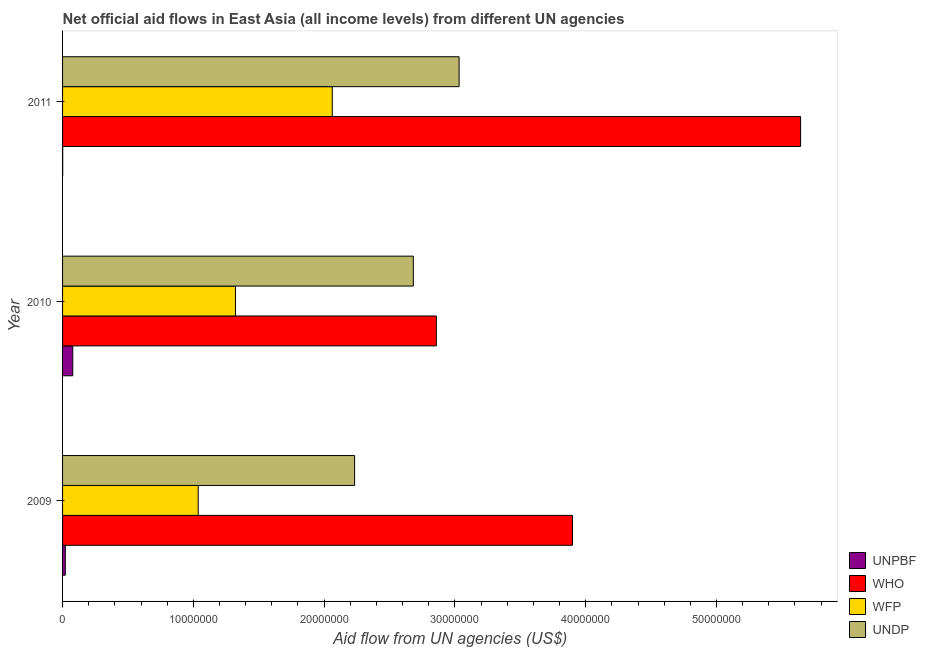How many different coloured bars are there?
Provide a short and direct response. 4. Are the number of bars on each tick of the Y-axis equal?
Make the answer very short. Yes. How many bars are there on the 2nd tick from the top?
Provide a succinct answer. 4. How many bars are there on the 1st tick from the bottom?
Offer a very short reply. 4. What is the amount of aid given by wfp in 2011?
Ensure brevity in your answer.  2.06e+07. Across all years, what is the maximum amount of aid given by undp?
Offer a very short reply. 3.03e+07. Across all years, what is the minimum amount of aid given by undp?
Provide a short and direct response. 2.23e+07. In which year was the amount of aid given by wfp maximum?
Your answer should be very brief. 2011. In which year was the amount of aid given by unpbf minimum?
Provide a short and direct response. 2011. What is the total amount of aid given by undp in the graph?
Offer a very short reply. 7.95e+07. What is the difference between the amount of aid given by unpbf in 2010 and that in 2011?
Provide a succinct answer. 7.70e+05. What is the difference between the amount of aid given by wfp in 2009 and the amount of aid given by who in 2011?
Offer a terse response. -4.61e+07. What is the average amount of aid given by undp per year?
Offer a very short reply. 2.65e+07. In the year 2011, what is the difference between the amount of aid given by undp and amount of aid given by unpbf?
Ensure brevity in your answer.  3.03e+07. In how many years, is the amount of aid given by who greater than 52000000 US$?
Provide a short and direct response. 1. What is the ratio of the amount of aid given by wfp in 2009 to that in 2011?
Provide a succinct answer. 0.5. Is the difference between the amount of aid given by wfp in 2010 and 2011 greater than the difference between the amount of aid given by unpbf in 2010 and 2011?
Keep it short and to the point. No. What is the difference between the highest and the second highest amount of aid given by undp?
Provide a succinct answer. 3.50e+06. What is the difference between the highest and the lowest amount of aid given by unpbf?
Your answer should be compact. 7.70e+05. In how many years, is the amount of aid given by undp greater than the average amount of aid given by undp taken over all years?
Give a very brief answer. 2. Is it the case that in every year, the sum of the amount of aid given by who and amount of aid given by wfp is greater than the sum of amount of aid given by undp and amount of aid given by unpbf?
Your answer should be very brief. Yes. What does the 3rd bar from the top in 2011 represents?
Provide a succinct answer. WHO. What does the 4th bar from the bottom in 2009 represents?
Offer a terse response. UNDP. Is it the case that in every year, the sum of the amount of aid given by unpbf and amount of aid given by who is greater than the amount of aid given by wfp?
Give a very brief answer. Yes. Are all the bars in the graph horizontal?
Make the answer very short. Yes. How many years are there in the graph?
Give a very brief answer. 3. Are the values on the major ticks of X-axis written in scientific E-notation?
Ensure brevity in your answer.  No. Does the graph contain any zero values?
Provide a succinct answer. No. How are the legend labels stacked?
Provide a succinct answer. Vertical. What is the title of the graph?
Give a very brief answer. Net official aid flows in East Asia (all income levels) from different UN agencies. Does "Australia" appear as one of the legend labels in the graph?
Your answer should be compact. No. What is the label or title of the X-axis?
Offer a terse response. Aid flow from UN agencies (US$). What is the Aid flow from UN agencies (US$) of WHO in 2009?
Make the answer very short. 3.90e+07. What is the Aid flow from UN agencies (US$) in WFP in 2009?
Offer a terse response. 1.04e+07. What is the Aid flow from UN agencies (US$) in UNDP in 2009?
Offer a terse response. 2.23e+07. What is the Aid flow from UN agencies (US$) of UNPBF in 2010?
Your response must be concise. 7.80e+05. What is the Aid flow from UN agencies (US$) of WHO in 2010?
Provide a succinct answer. 2.86e+07. What is the Aid flow from UN agencies (US$) of WFP in 2010?
Keep it short and to the point. 1.32e+07. What is the Aid flow from UN agencies (US$) of UNDP in 2010?
Offer a very short reply. 2.68e+07. What is the Aid flow from UN agencies (US$) in WHO in 2011?
Provide a succinct answer. 5.64e+07. What is the Aid flow from UN agencies (US$) in WFP in 2011?
Ensure brevity in your answer.  2.06e+07. What is the Aid flow from UN agencies (US$) in UNDP in 2011?
Your answer should be very brief. 3.03e+07. Across all years, what is the maximum Aid flow from UN agencies (US$) of UNPBF?
Your answer should be compact. 7.80e+05. Across all years, what is the maximum Aid flow from UN agencies (US$) in WHO?
Give a very brief answer. 5.64e+07. Across all years, what is the maximum Aid flow from UN agencies (US$) of WFP?
Your answer should be compact. 2.06e+07. Across all years, what is the maximum Aid flow from UN agencies (US$) of UNDP?
Your response must be concise. 3.03e+07. Across all years, what is the minimum Aid flow from UN agencies (US$) in WHO?
Ensure brevity in your answer.  2.86e+07. Across all years, what is the minimum Aid flow from UN agencies (US$) of WFP?
Keep it short and to the point. 1.04e+07. Across all years, what is the minimum Aid flow from UN agencies (US$) in UNDP?
Give a very brief answer. 2.23e+07. What is the total Aid flow from UN agencies (US$) of UNPBF in the graph?
Offer a very short reply. 1.00e+06. What is the total Aid flow from UN agencies (US$) in WHO in the graph?
Your answer should be very brief. 1.24e+08. What is the total Aid flow from UN agencies (US$) of WFP in the graph?
Your answer should be compact. 4.42e+07. What is the total Aid flow from UN agencies (US$) in UNDP in the graph?
Offer a very short reply. 7.95e+07. What is the difference between the Aid flow from UN agencies (US$) in UNPBF in 2009 and that in 2010?
Your answer should be compact. -5.70e+05. What is the difference between the Aid flow from UN agencies (US$) in WHO in 2009 and that in 2010?
Your answer should be compact. 1.04e+07. What is the difference between the Aid flow from UN agencies (US$) in WFP in 2009 and that in 2010?
Provide a succinct answer. -2.85e+06. What is the difference between the Aid flow from UN agencies (US$) of UNDP in 2009 and that in 2010?
Your answer should be very brief. -4.49e+06. What is the difference between the Aid flow from UN agencies (US$) in UNPBF in 2009 and that in 2011?
Offer a very short reply. 2.00e+05. What is the difference between the Aid flow from UN agencies (US$) of WHO in 2009 and that in 2011?
Your answer should be compact. -1.74e+07. What is the difference between the Aid flow from UN agencies (US$) in WFP in 2009 and that in 2011?
Give a very brief answer. -1.02e+07. What is the difference between the Aid flow from UN agencies (US$) of UNDP in 2009 and that in 2011?
Provide a succinct answer. -7.99e+06. What is the difference between the Aid flow from UN agencies (US$) of UNPBF in 2010 and that in 2011?
Your answer should be compact. 7.70e+05. What is the difference between the Aid flow from UN agencies (US$) of WHO in 2010 and that in 2011?
Ensure brevity in your answer.  -2.78e+07. What is the difference between the Aid flow from UN agencies (US$) in WFP in 2010 and that in 2011?
Ensure brevity in your answer.  -7.40e+06. What is the difference between the Aid flow from UN agencies (US$) in UNDP in 2010 and that in 2011?
Provide a succinct answer. -3.50e+06. What is the difference between the Aid flow from UN agencies (US$) of UNPBF in 2009 and the Aid flow from UN agencies (US$) of WHO in 2010?
Your answer should be compact. -2.84e+07. What is the difference between the Aid flow from UN agencies (US$) of UNPBF in 2009 and the Aid flow from UN agencies (US$) of WFP in 2010?
Make the answer very short. -1.30e+07. What is the difference between the Aid flow from UN agencies (US$) of UNPBF in 2009 and the Aid flow from UN agencies (US$) of UNDP in 2010?
Provide a succinct answer. -2.66e+07. What is the difference between the Aid flow from UN agencies (US$) in WHO in 2009 and the Aid flow from UN agencies (US$) in WFP in 2010?
Offer a terse response. 2.58e+07. What is the difference between the Aid flow from UN agencies (US$) of WHO in 2009 and the Aid flow from UN agencies (US$) of UNDP in 2010?
Provide a short and direct response. 1.22e+07. What is the difference between the Aid flow from UN agencies (US$) of WFP in 2009 and the Aid flow from UN agencies (US$) of UNDP in 2010?
Your answer should be compact. -1.64e+07. What is the difference between the Aid flow from UN agencies (US$) of UNPBF in 2009 and the Aid flow from UN agencies (US$) of WHO in 2011?
Ensure brevity in your answer.  -5.62e+07. What is the difference between the Aid flow from UN agencies (US$) in UNPBF in 2009 and the Aid flow from UN agencies (US$) in WFP in 2011?
Offer a terse response. -2.04e+07. What is the difference between the Aid flow from UN agencies (US$) in UNPBF in 2009 and the Aid flow from UN agencies (US$) in UNDP in 2011?
Your response must be concise. -3.01e+07. What is the difference between the Aid flow from UN agencies (US$) of WHO in 2009 and the Aid flow from UN agencies (US$) of WFP in 2011?
Offer a terse response. 1.84e+07. What is the difference between the Aid flow from UN agencies (US$) in WHO in 2009 and the Aid flow from UN agencies (US$) in UNDP in 2011?
Offer a terse response. 8.67e+06. What is the difference between the Aid flow from UN agencies (US$) of WFP in 2009 and the Aid flow from UN agencies (US$) of UNDP in 2011?
Your response must be concise. -2.00e+07. What is the difference between the Aid flow from UN agencies (US$) of UNPBF in 2010 and the Aid flow from UN agencies (US$) of WHO in 2011?
Your response must be concise. -5.56e+07. What is the difference between the Aid flow from UN agencies (US$) in UNPBF in 2010 and the Aid flow from UN agencies (US$) in WFP in 2011?
Ensure brevity in your answer.  -1.98e+07. What is the difference between the Aid flow from UN agencies (US$) in UNPBF in 2010 and the Aid flow from UN agencies (US$) in UNDP in 2011?
Offer a very short reply. -2.95e+07. What is the difference between the Aid flow from UN agencies (US$) of WHO in 2010 and the Aid flow from UN agencies (US$) of WFP in 2011?
Give a very brief answer. 7.96e+06. What is the difference between the Aid flow from UN agencies (US$) in WHO in 2010 and the Aid flow from UN agencies (US$) in UNDP in 2011?
Give a very brief answer. -1.74e+06. What is the difference between the Aid flow from UN agencies (US$) of WFP in 2010 and the Aid flow from UN agencies (US$) of UNDP in 2011?
Give a very brief answer. -1.71e+07. What is the average Aid flow from UN agencies (US$) in UNPBF per year?
Your answer should be very brief. 3.33e+05. What is the average Aid flow from UN agencies (US$) in WHO per year?
Provide a succinct answer. 4.13e+07. What is the average Aid flow from UN agencies (US$) in WFP per year?
Your answer should be very brief. 1.47e+07. What is the average Aid flow from UN agencies (US$) of UNDP per year?
Provide a short and direct response. 2.65e+07. In the year 2009, what is the difference between the Aid flow from UN agencies (US$) of UNPBF and Aid flow from UN agencies (US$) of WHO?
Provide a succinct answer. -3.88e+07. In the year 2009, what is the difference between the Aid flow from UN agencies (US$) of UNPBF and Aid flow from UN agencies (US$) of WFP?
Your response must be concise. -1.02e+07. In the year 2009, what is the difference between the Aid flow from UN agencies (US$) in UNPBF and Aid flow from UN agencies (US$) in UNDP?
Keep it short and to the point. -2.21e+07. In the year 2009, what is the difference between the Aid flow from UN agencies (US$) of WHO and Aid flow from UN agencies (US$) of WFP?
Offer a terse response. 2.86e+07. In the year 2009, what is the difference between the Aid flow from UN agencies (US$) in WHO and Aid flow from UN agencies (US$) in UNDP?
Offer a terse response. 1.67e+07. In the year 2009, what is the difference between the Aid flow from UN agencies (US$) in WFP and Aid flow from UN agencies (US$) in UNDP?
Offer a terse response. -1.20e+07. In the year 2010, what is the difference between the Aid flow from UN agencies (US$) in UNPBF and Aid flow from UN agencies (US$) in WHO?
Your answer should be compact. -2.78e+07. In the year 2010, what is the difference between the Aid flow from UN agencies (US$) in UNPBF and Aid flow from UN agencies (US$) in WFP?
Offer a very short reply. -1.24e+07. In the year 2010, what is the difference between the Aid flow from UN agencies (US$) of UNPBF and Aid flow from UN agencies (US$) of UNDP?
Your answer should be compact. -2.60e+07. In the year 2010, what is the difference between the Aid flow from UN agencies (US$) in WHO and Aid flow from UN agencies (US$) in WFP?
Your answer should be very brief. 1.54e+07. In the year 2010, what is the difference between the Aid flow from UN agencies (US$) of WHO and Aid flow from UN agencies (US$) of UNDP?
Keep it short and to the point. 1.76e+06. In the year 2010, what is the difference between the Aid flow from UN agencies (US$) of WFP and Aid flow from UN agencies (US$) of UNDP?
Give a very brief answer. -1.36e+07. In the year 2011, what is the difference between the Aid flow from UN agencies (US$) of UNPBF and Aid flow from UN agencies (US$) of WHO?
Offer a terse response. -5.64e+07. In the year 2011, what is the difference between the Aid flow from UN agencies (US$) of UNPBF and Aid flow from UN agencies (US$) of WFP?
Keep it short and to the point. -2.06e+07. In the year 2011, what is the difference between the Aid flow from UN agencies (US$) in UNPBF and Aid flow from UN agencies (US$) in UNDP?
Your answer should be very brief. -3.03e+07. In the year 2011, what is the difference between the Aid flow from UN agencies (US$) of WHO and Aid flow from UN agencies (US$) of WFP?
Ensure brevity in your answer.  3.58e+07. In the year 2011, what is the difference between the Aid flow from UN agencies (US$) in WHO and Aid flow from UN agencies (US$) in UNDP?
Offer a terse response. 2.61e+07. In the year 2011, what is the difference between the Aid flow from UN agencies (US$) in WFP and Aid flow from UN agencies (US$) in UNDP?
Offer a terse response. -9.70e+06. What is the ratio of the Aid flow from UN agencies (US$) in UNPBF in 2009 to that in 2010?
Provide a short and direct response. 0.27. What is the ratio of the Aid flow from UN agencies (US$) of WHO in 2009 to that in 2010?
Offer a very short reply. 1.36. What is the ratio of the Aid flow from UN agencies (US$) in WFP in 2009 to that in 2010?
Provide a succinct answer. 0.78. What is the ratio of the Aid flow from UN agencies (US$) in UNDP in 2009 to that in 2010?
Offer a terse response. 0.83. What is the ratio of the Aid flow from UN agencies (US$) in WHO in 2009 to that in 2011?
Your answer should be compact. 0.69. What is the ratio of the Aid flow from UN agencies (US$) of WFP in 2009 to that in 2011?
Provide a succinct answer. 0.5. What is the ratio of the Aid flow from UN agencies (US$) of UNDP in 2009 to that in 2011?
Your answer should be very brief. 0.74. What is the ratio of the Aid flow from UN agencies (US$) of UNPBF in 2010 to that in 2011?
Your response must be concise. 78. What is the ratio of the Aid flow from UN agencies (US$) of WHO in 2010 to that in 2011?
Make the answer very short. 0.51. What is the ratio of the Aid flow from UN agencies (US$) of WFP in 2010 to that in 2011?
Your answer should be compact. 0.64. What is the ratio of the Aid flow from UN agencies (US$) of UNDP in 2010 to that in 2011?
Give a very brief answer. 0.88. What is the difference between the highest and the second highest Aid flow from UN agencies (US$) in UNPBF?
Provide a short and direct response. 5.70e+05. What is the difference between the highest and the second highest Aid flow from UN agencies (US$) of WHO?
Provide a succinct answer. 1.74e+07. What is the difference between the highest and the second highest Aid flow from UN agencies (US$) of WFP?
Provide a succinct answer. 7.40e+06. What is the difference between the highest and the second highest Aid flow from UN agencies (US$) in UNDP?
Offer a very short reply. 3.50e+06. What is the difference between the highest and the lowest Aid flow from UN agencies (US$) of UNPBF?
Keep it short and to the point. 7.70e+05. What is the difference between the highest and the lowest Aid flow from UN agencies (US$) in WHO?
Your answer should be very brief. 2.78e+07. What is the difference between the highest and the lowest Aid flow from UN agencies (US$) in WFP?
Make the answer very short. 1.02e+07. What is the difference between the highest and the lowest Aid flow from UN agencies (US$) in UNDP?
Keep it short and to the point. 7.99e+06. 